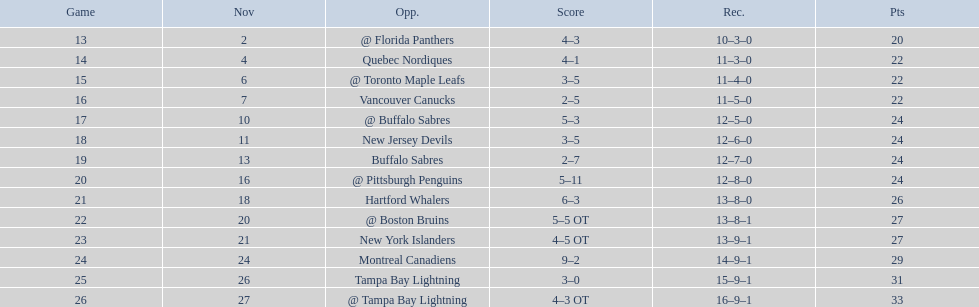Who are all of the teams? @ Florida Panthers, Quebec Nordiques, @ Toronto Maple Leafs, Vancouver Canucks, @ Buffalo Sabres, New Jersey Devils, Buffalo Sabres, @ Pittsburgh Penguins, Hartford Whalers, @ Boston Bruins, New York Islanders, Montreal Canadiens, Tampa Bay Lightning. What games finished in overtime? 22, 23, 26. In game number 23, who did they face? New York Islanders. 